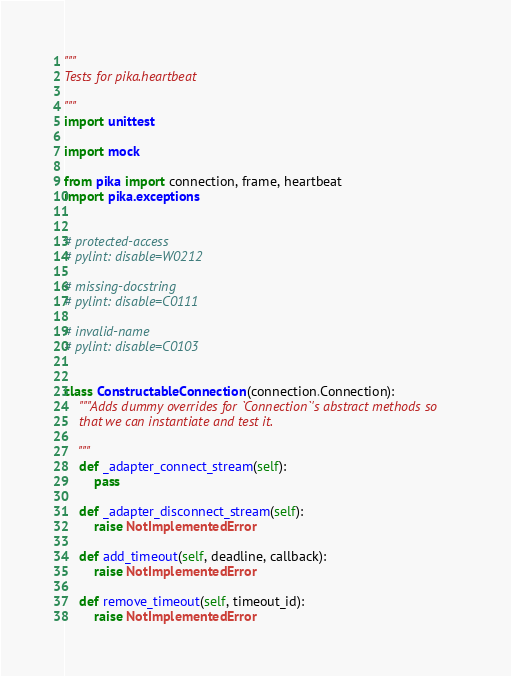<code> <loc_0><loc_0><loc_500><loc_500><_Python_>"""
Tests for pika.heartbeat

"""
import unittest

import mock

from pika import connection, frame, heartbeat
import pika.exceptions


# protected-access
# pylint: disable=W0212

# missing-docstring
# pylint: disable=C0111

# invalid-name
# pylint: disable=C0103


class ConstructableConnection(connection.Connection):
    """Adds dummy overrides for `Connection`'s abstract methods so
    that we can instantiate and test it.

    """
    def _adapter_connect_stream(self):
        pass

    def _adapter_disconnect_stream(self):
        raise NotImplementedError

    def add_timeout(self, deadline, callback):
        raise NotImplementedError

    def remove_timeout(self, timeout_id):
        raise NotImplementedError
</code> 